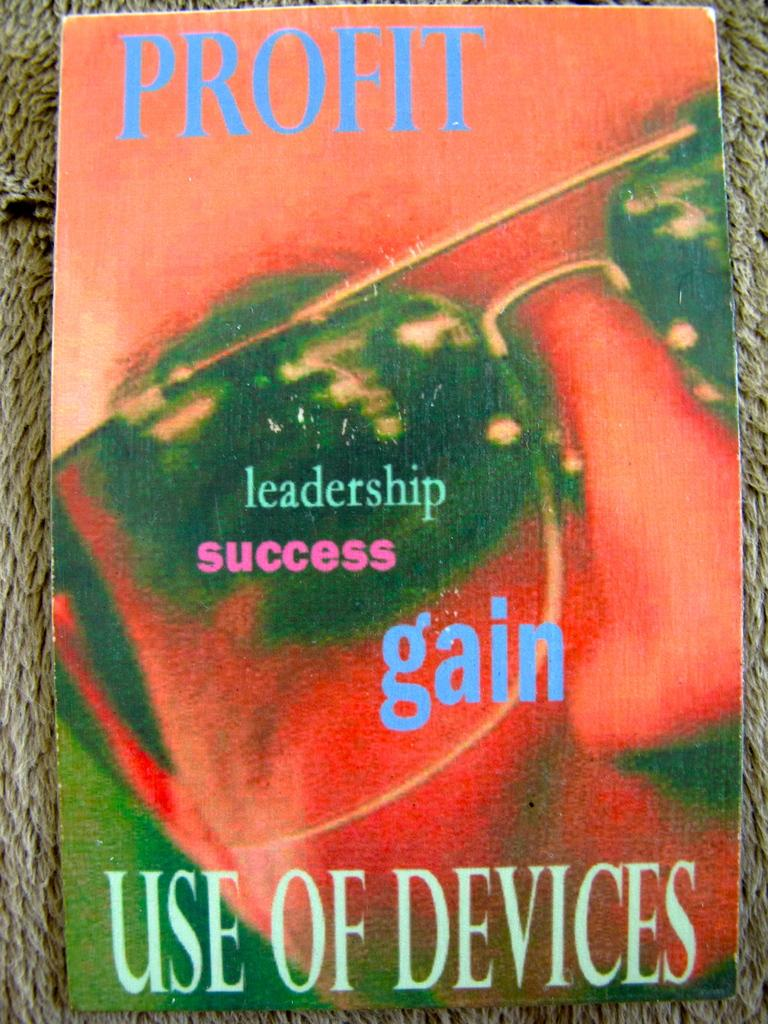Provide a one-sentence caption for the provided image. Profit use of devices that includes leadership success gain. 